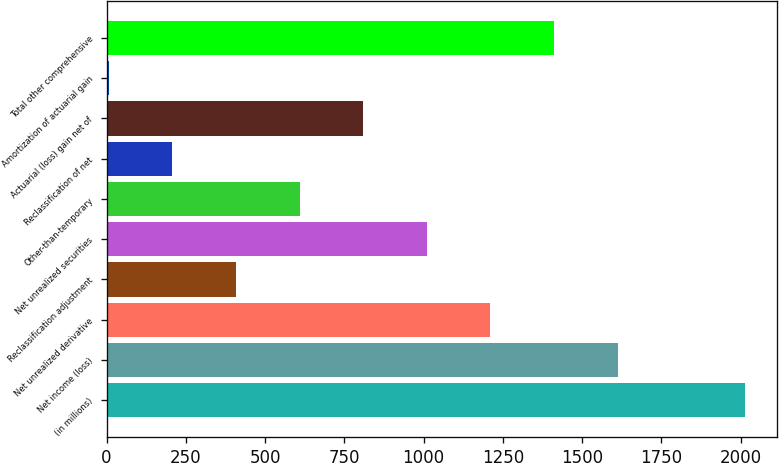Convert chart to OTSL. <chart><loc_0><loc_0><loc_500><loc_500><bar_chart><fcel>(in millions)<fcel>Net income (loss)<fcel>Net unrealized derivative<fcel>Reclassification adjustment<fcel>Net unrealized securities<fcel>Other-than-temporary<fcel>Reclassification of net<fcel>Actuarial (loss) gain net of<fcel>Amortization of actuarial gain<fcel>Total other comprehensive<nl><fcel>2014<fcel>1612.6<fcel>1211.2<fcel>408.4<fcel>1010.5<fcel>609.1<fcel>207.7<fcel>809.8<fcel>7<fcel>1411.9<nl></chart> 